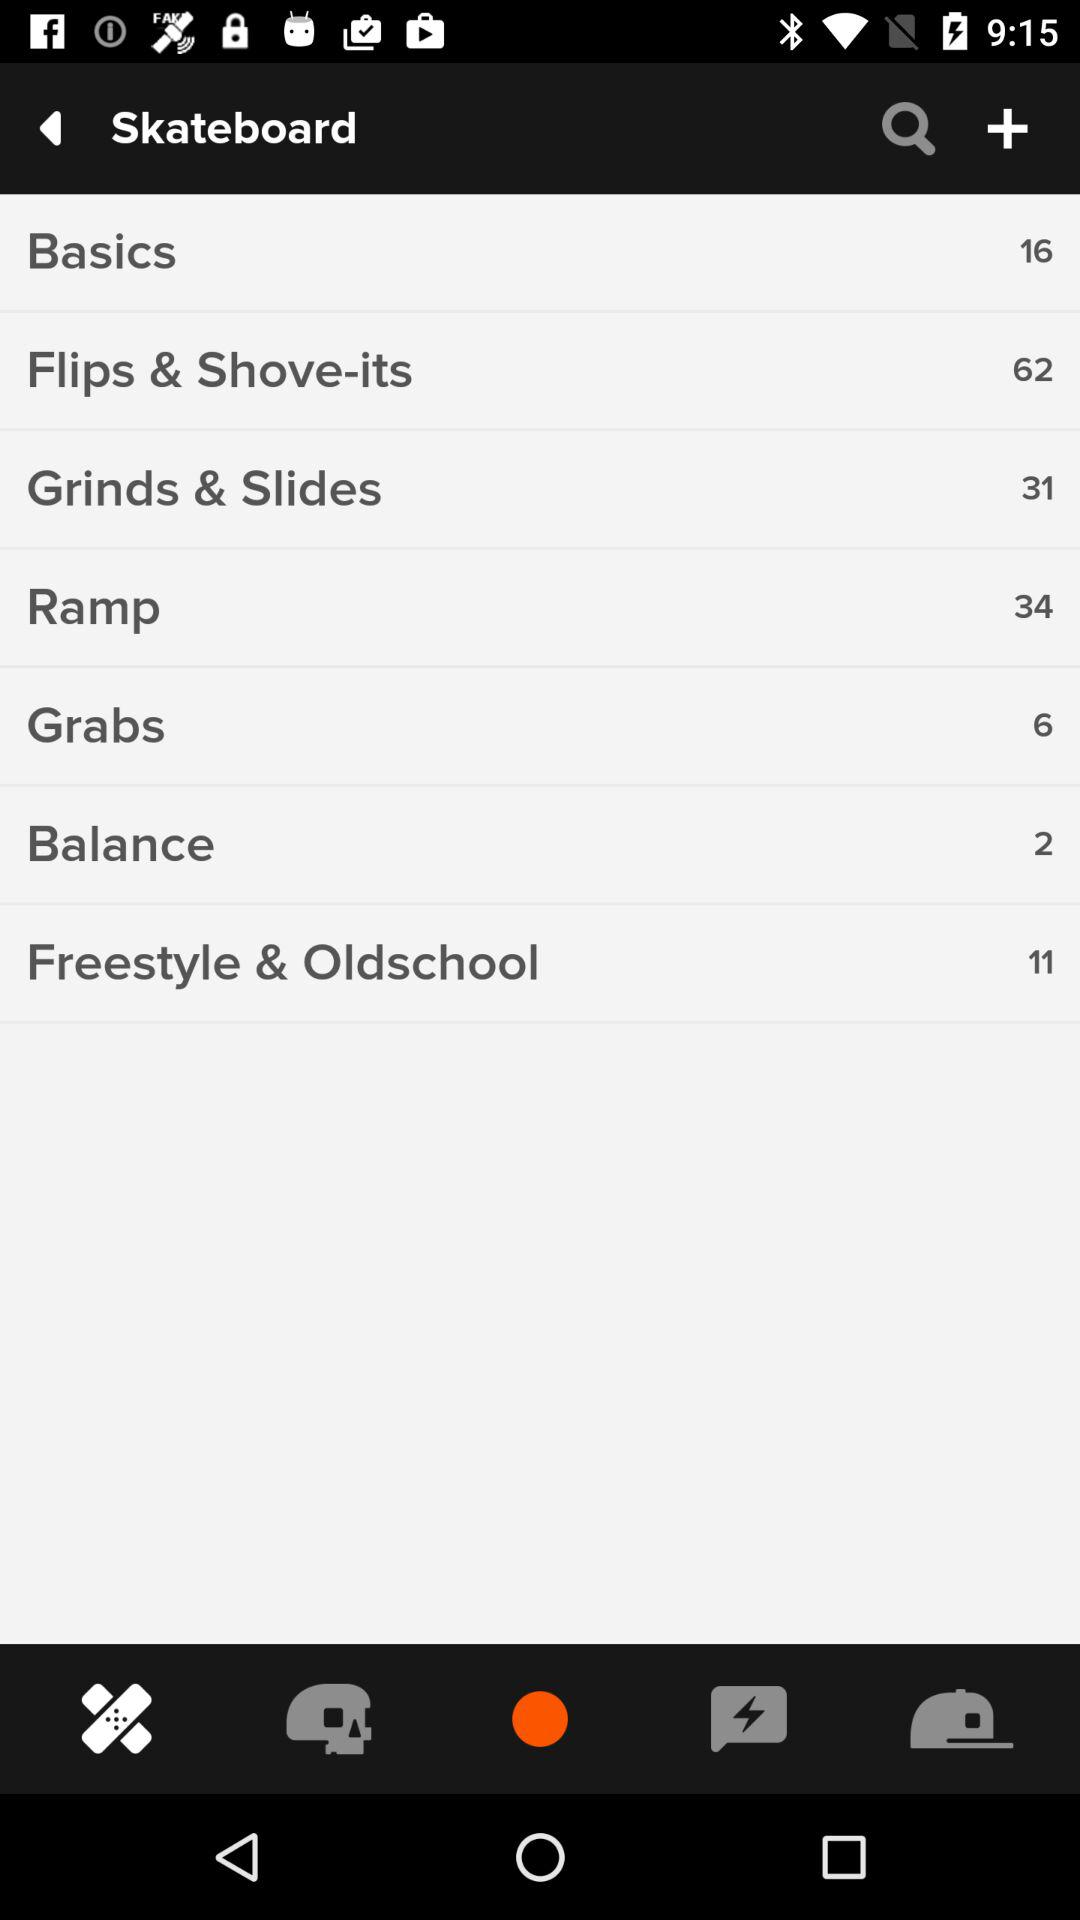How many "Flips & Shove-its" tricks are there on a skateboard? There are 62 "Flips & Shove-its" tricks on a skateboard. 